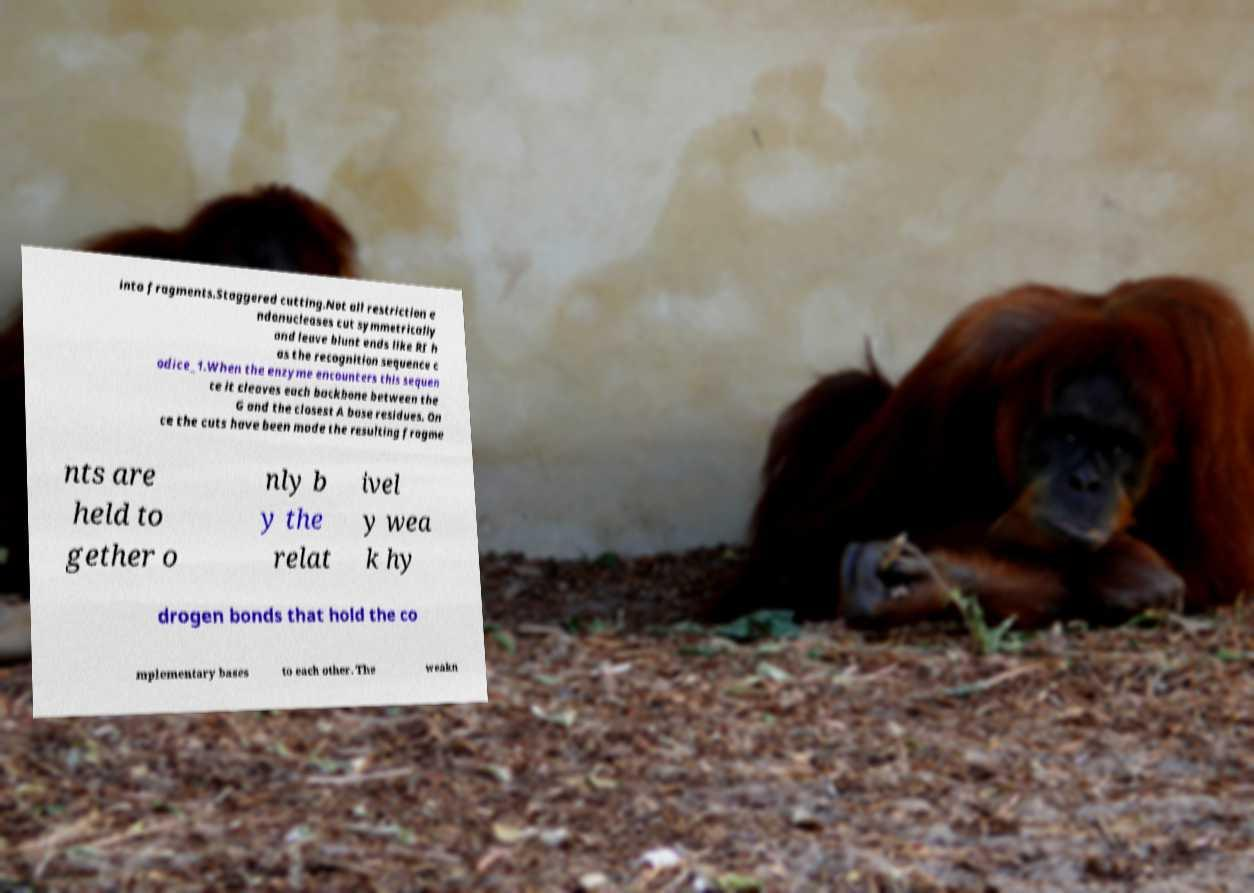Can you read and provide the text displayed in the image?This photo seems to have some interesting text. Can you extract and type it out for me? into fragments.Staggered cutting.Not all restriction e ndonucleases cut symmetrically and leave blunt ends like RI h as the recognition sequence c odice_1.When the enzyme encounters this sequen ce it cleaves each backbone between the G and the closest A base residues. On ce the cuts have been made the resulting fragme nts are held to gether o nly b y the relat ivel y wea k hy drogen bonds that hold the co mplementary bases to each other. The weakn 